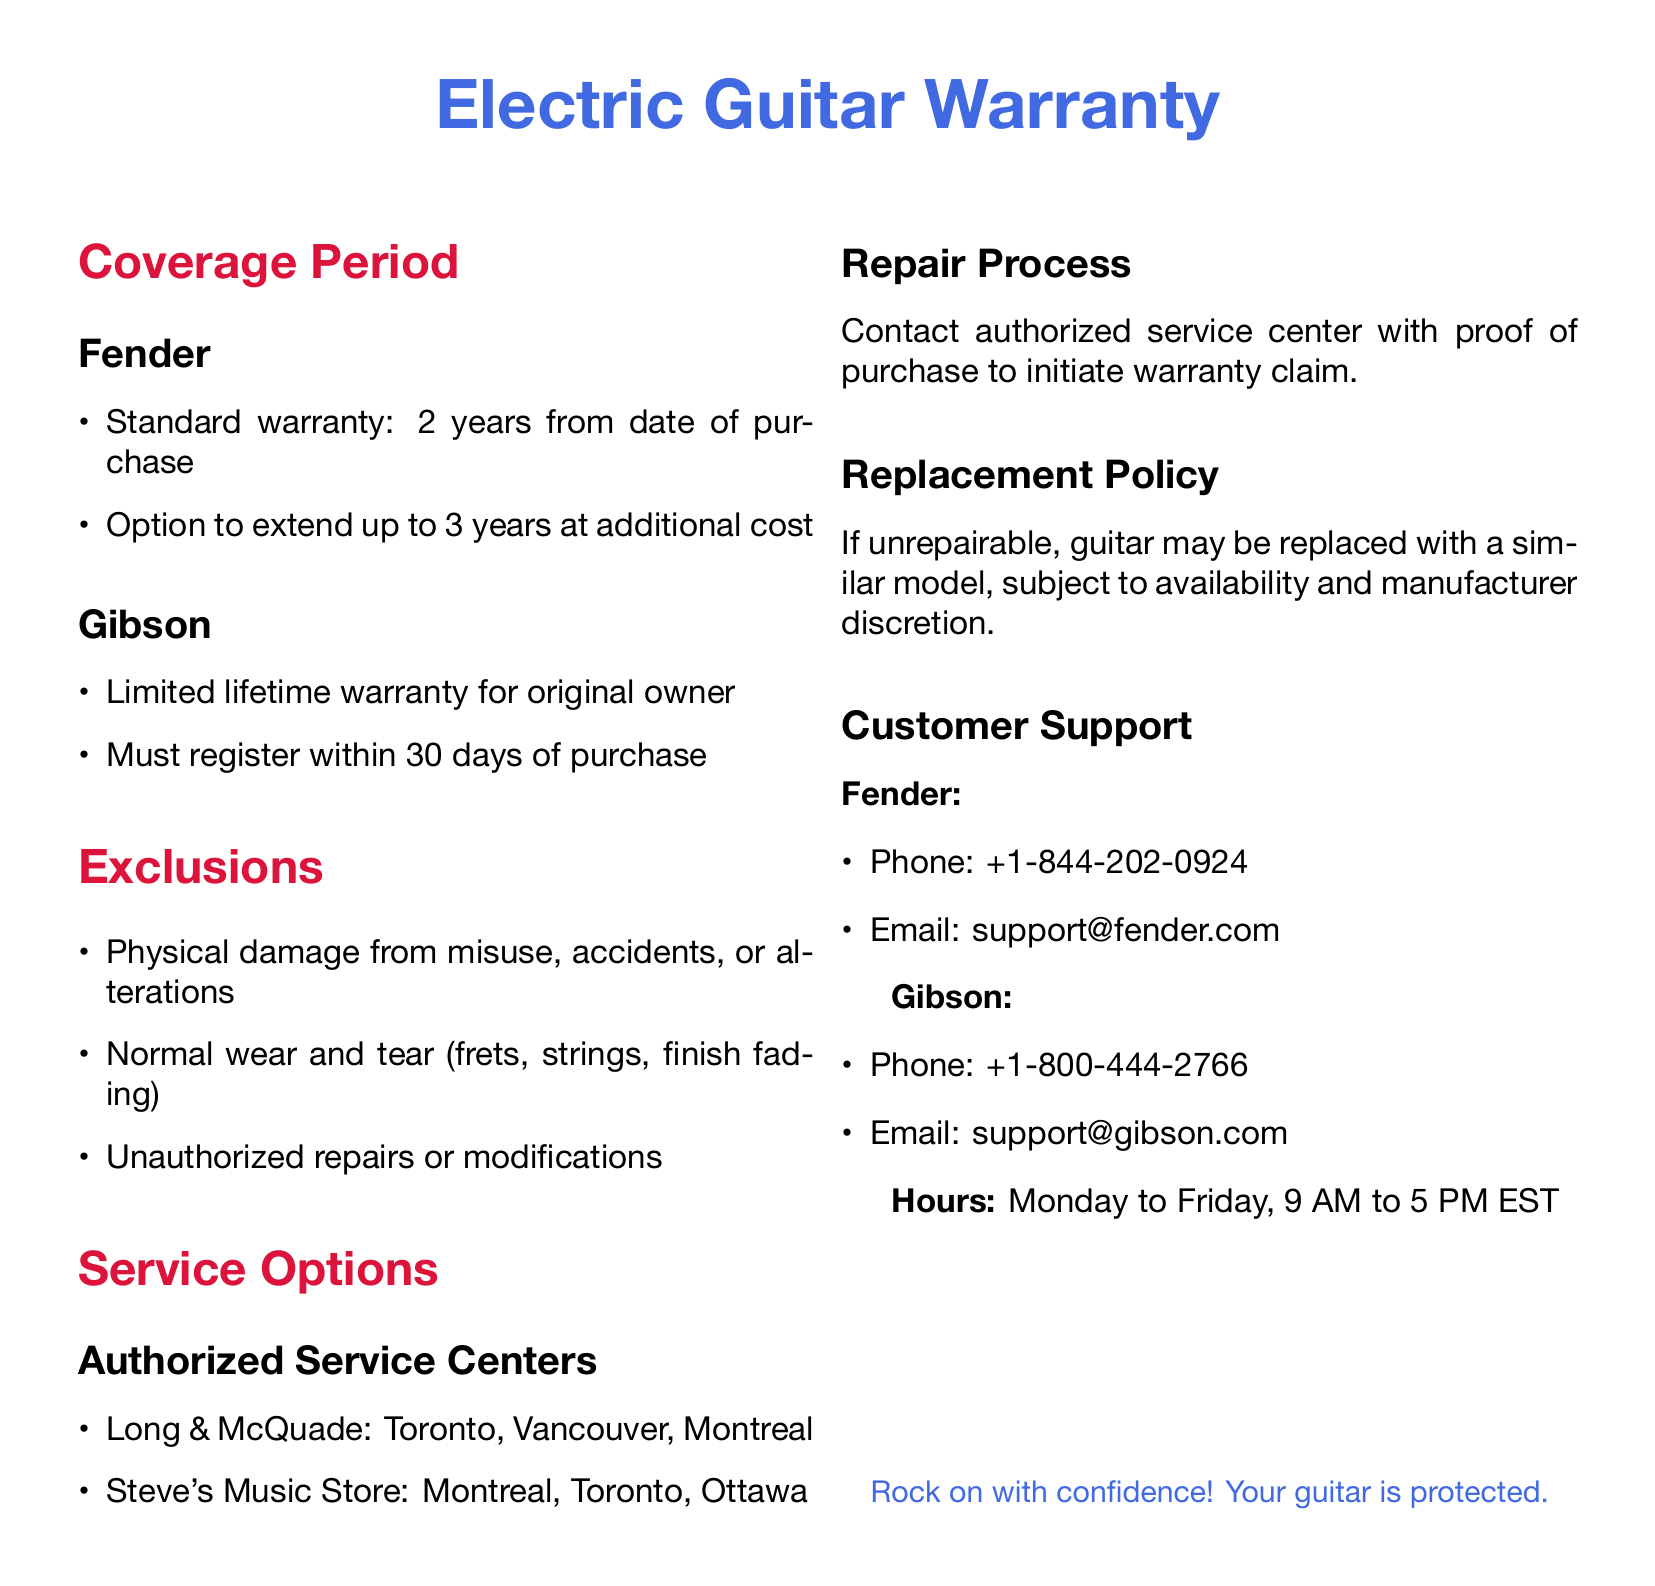What is the standard warranty period for Fender guitars? The standard warranty for Fender guitars is stated as 2 years from the date of purchase.
Answer: 2 years What must you do to receive the Gibson limited lifetime warranty? To receive the Gibson limited lifetime warranty, the original owner must register within 30 days of purchase.
Answer: Register within 30 days What types of damage are excluded from the warranty coverage? The document lists physical damage from misuse, accidents, alterations, and normal wear and tear as exclusions.
Answer: Physical damage, normal wear and tear Which service center is located in Vancouver? The authorized service center mentioned in the document with a location in Vancouver is Long & McQuade.
Answer: Long & McQuade What is the contact email for Fender customer support? The email address provided for Fender customer support is included in the document.
Answer: support@fender.com If a guitar is unrepairable, what may happen to it? According to the document, if a guitar is unrepairable, it may be replaced with a similar model.
Answer: Replaced with a similar model How many years is the option to extend the Fender warranty? The option to extend the Fender warranty is for an additional time period specified in the document.
Answer: 3 years What are the customer support hours for both Fender and Gibson? The document mentions specific operating hours for customer support: Monday to Friday, 9 AM to 5 PM EST.
Answer: 9 AM to 5 PM EST What do you need to initiate a warranty claim? To initiate a warranty claim, the document states you need proof of purchase to contact an authorized service center.
Answer: Proof of purchase 